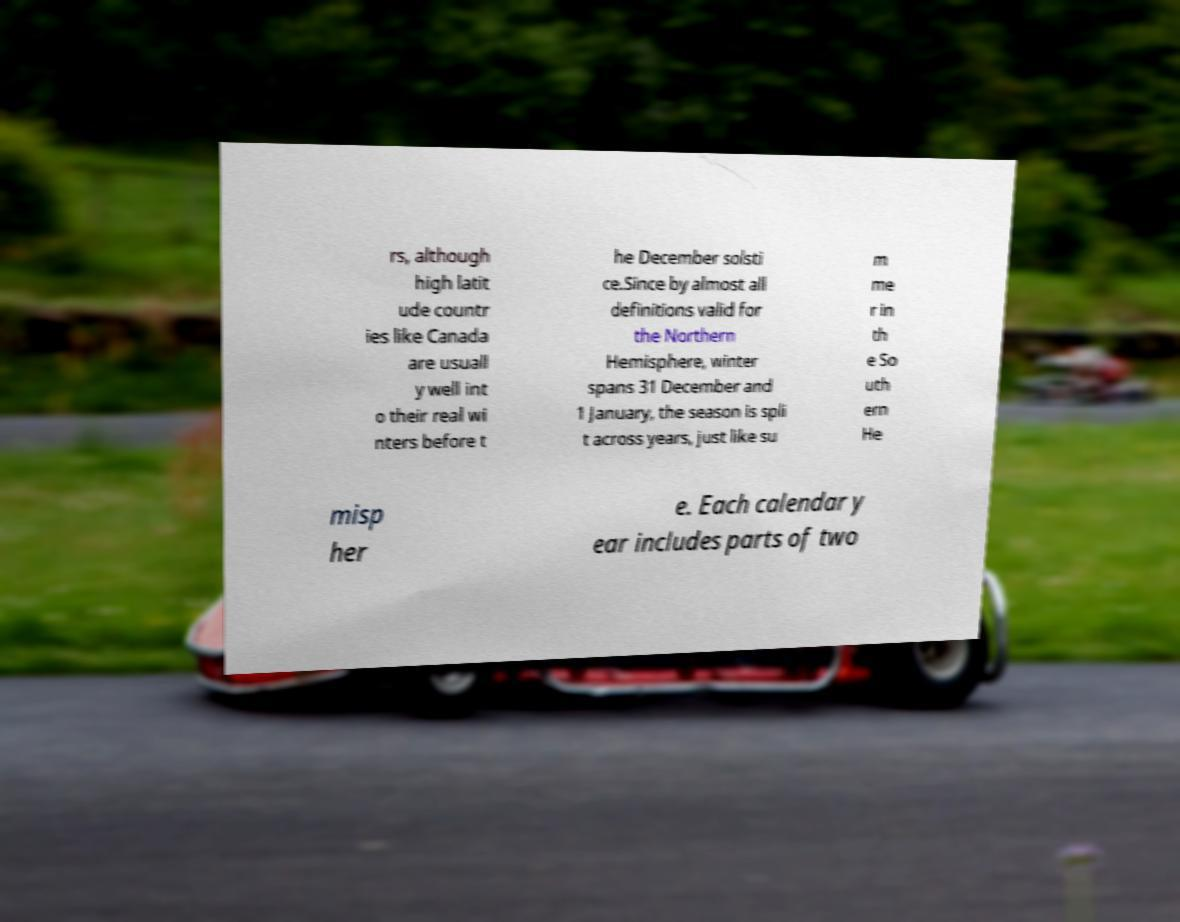Could you assist in decoding the text presented in this image and type it out clearly? rs, although high latit ude countr ies like Canada are usuall y well int o their real wi nters before t he December solsti ce.Since by almost all definitions valid for the Northern Hemisphere, winter spans 31 December and 1 January, the season is spli t across years, just like su m me r in th e So uth ern He misp her e. Each calendar y ear includes parts of two 